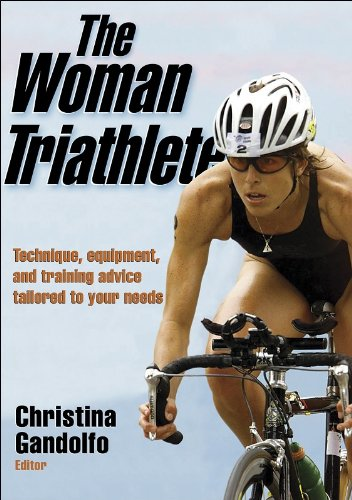Is this a games related book? Yes, it is games related. The book provides insights into the triathlon, which is a competitive sport involving swimming, cycling, and running, tailored for active and aspiring female athletes. 